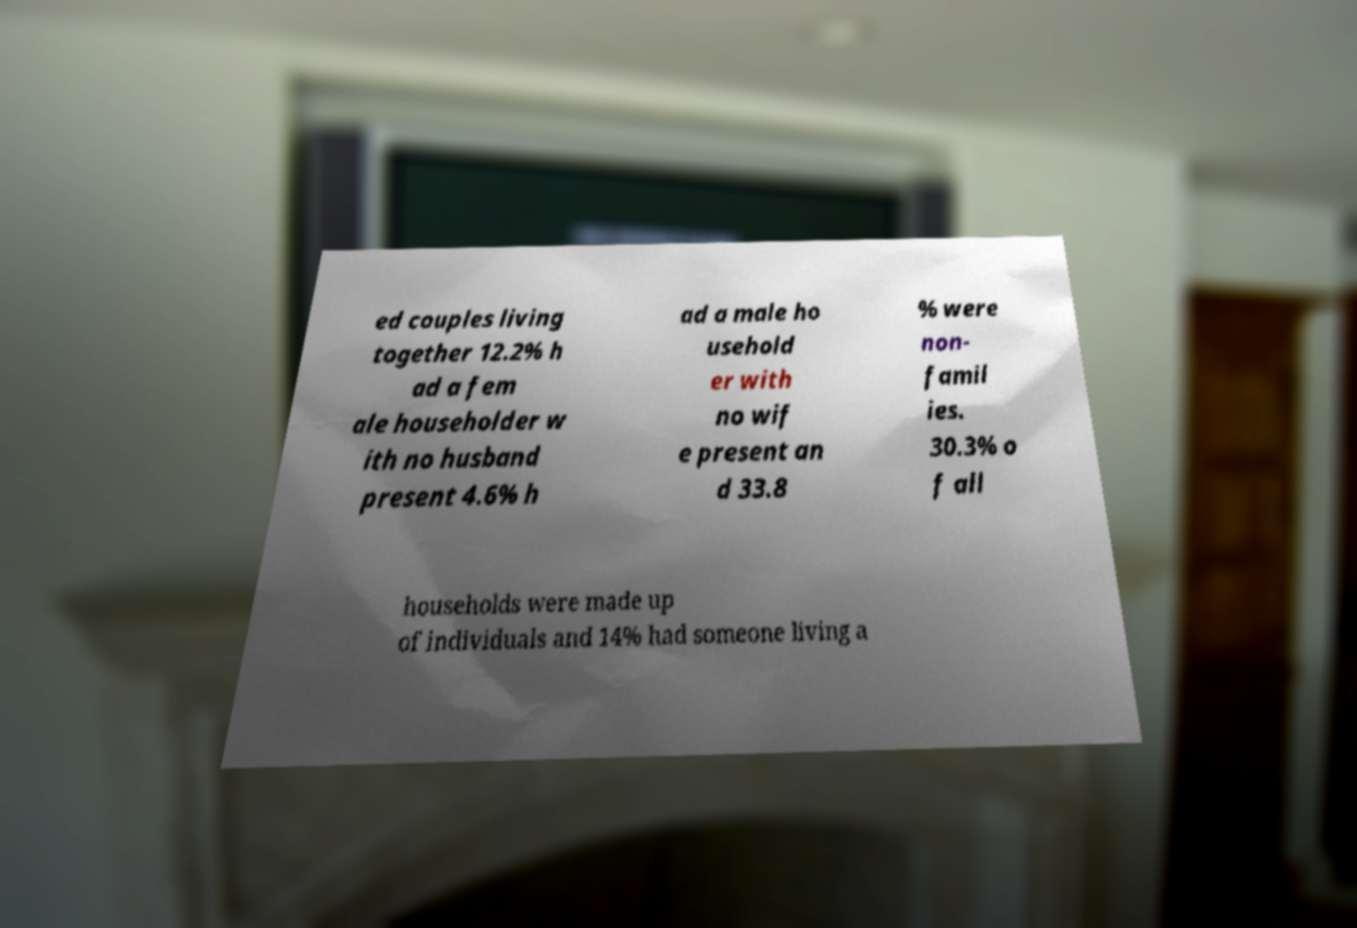Can you read and provide the text displayed in the image?This photo seems to have some interesting text. Can you extract and type it out for me? ed couples living together 12.2% h ad a fem ale householder w ith no husband present 4.6% h ad a male ho usehold er with no wif e present an d 33.8 % were non- famil ies. 30.3% o f all households were made up of individuals and 14% had someone living a 